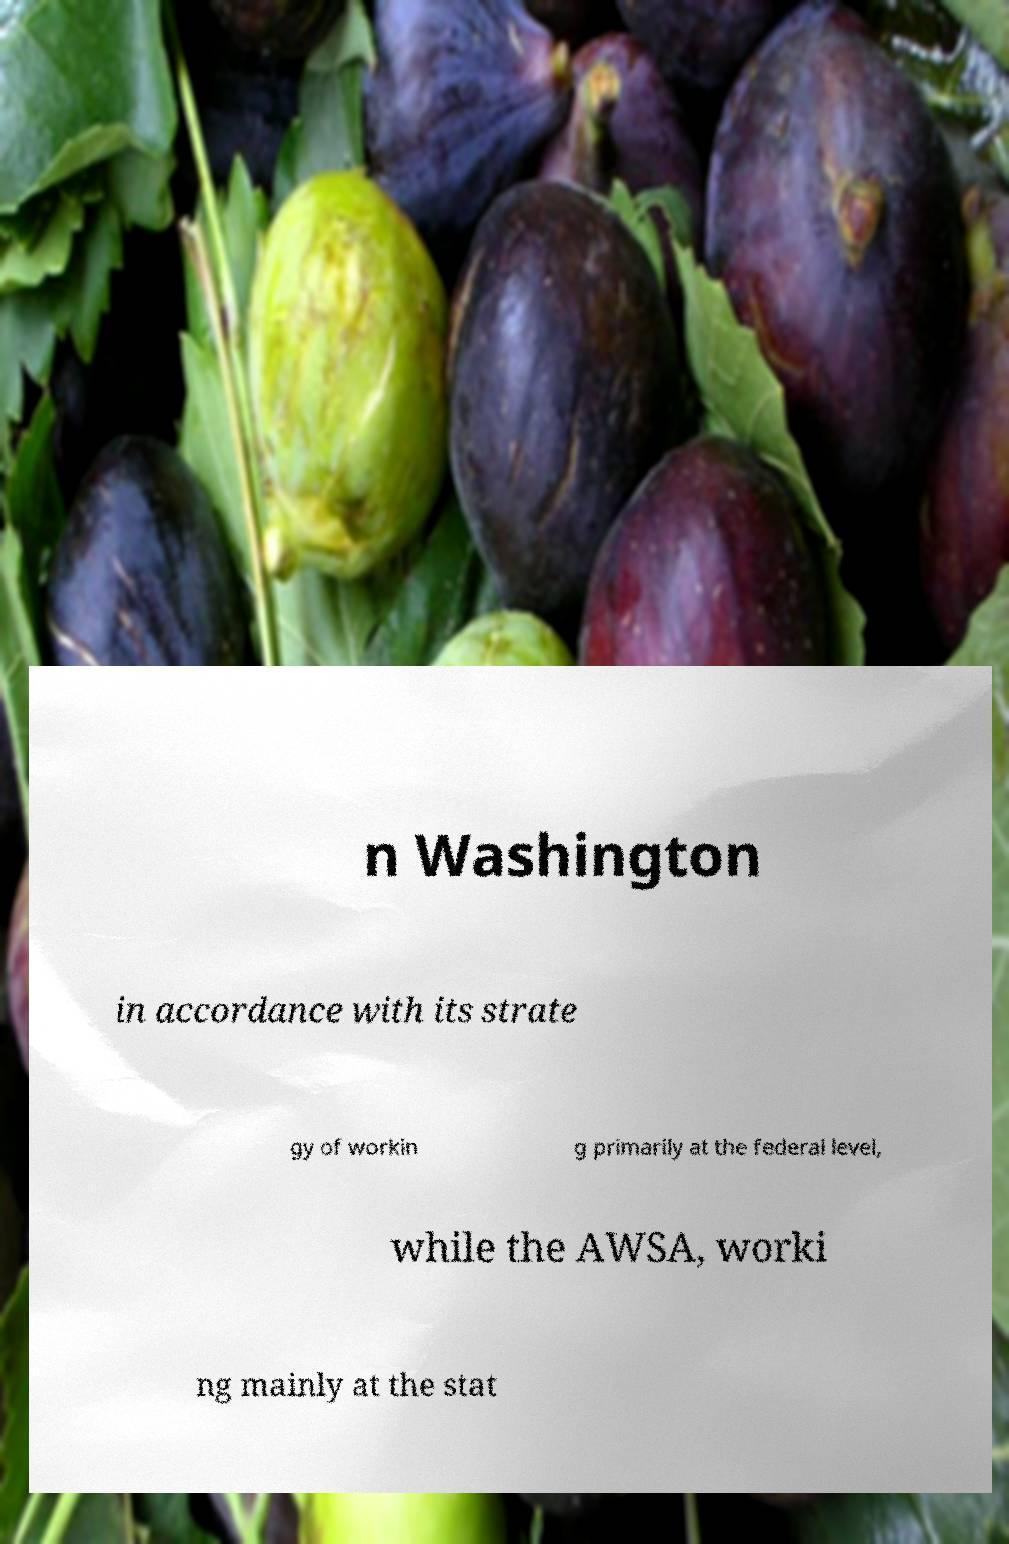Could you extract and type out the text from this image? n Washington in accordance with its strate gy of workin g primarily at the federal level, while the AWSA, worki ng mainly at the stat 